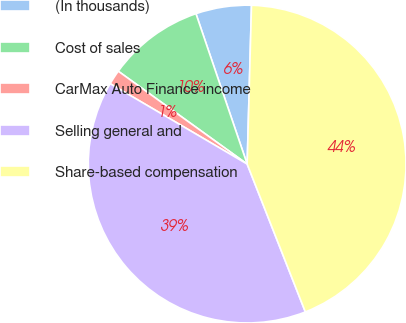Convert chart to OTSL. <chart><loc_0><loc_0><loc_500><loc_500><pie_chart><fcel>(In thousands)<fcel>Cost of sales<fcel>CarMax Auto Finance income<fcel>Selling general and<fcel>Share-based compensation<nl><fcel>5.66%<fcel>9.84%<fcel>1.49%<fcel>39.42%<fcel>43.6%<nl></chart> 